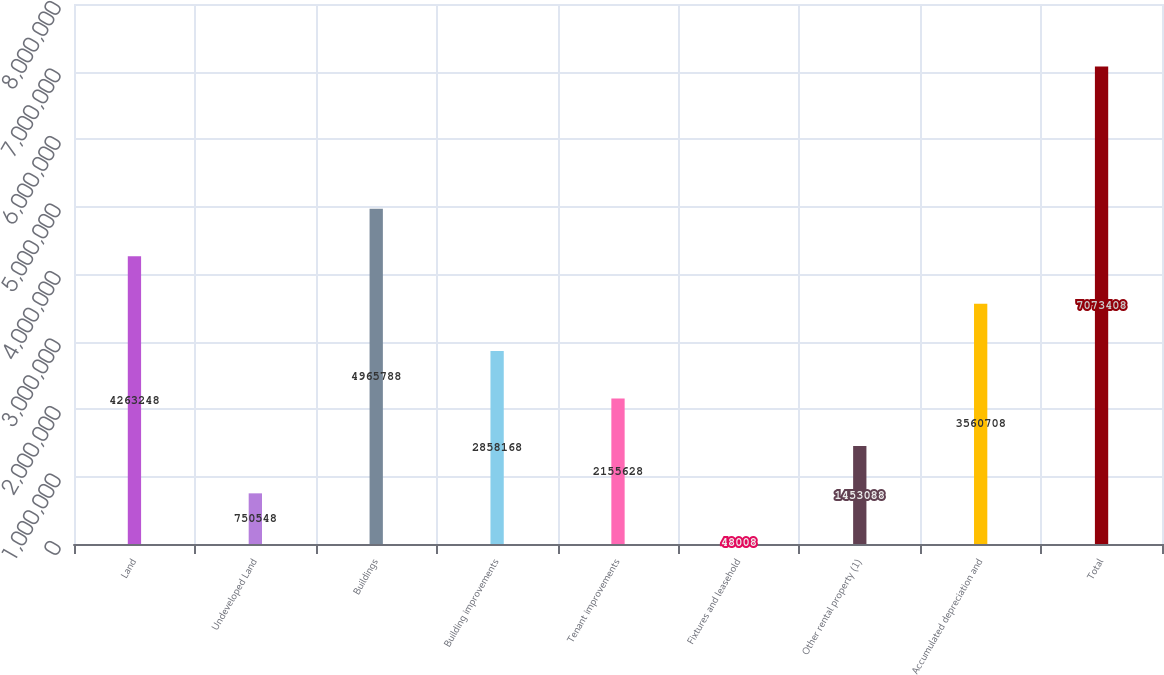Convert chart. <chart><loc_0><loc_0><loc_500><loc_500><bar_chart><fcel>Land<fcel>Undeveloped Land<fcel>Buildings<fcel>Building improvements<fcel>Tenant improvements<fcel>Fixtures and leasehold<fcel>Other rental property (1)<fcel>Accumulated depreciation and<fcel>Total<nl><fcel>4.26325e+06<fcel>750548<fcel>4.96579e+06<fcel>2.85817e+06<fcel>2.15563e+06<fcel>48008<fcel>1.45309e+06<fcel>3.56071e+06<fcel>7.07341e+06<nl></chart> 